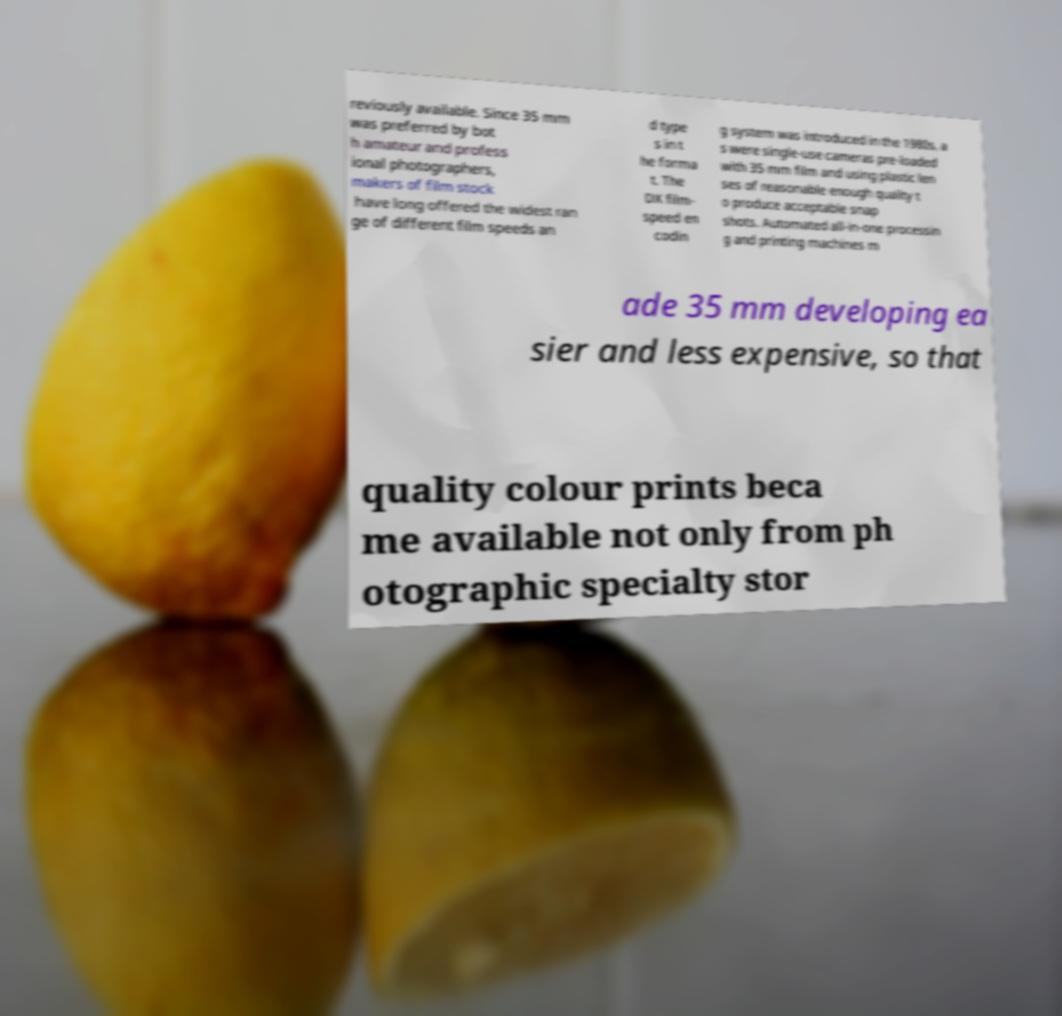Can you read and provide the text displayed in the image?This photo seems to have some interesting text. Can you extract and type it out for me? reviously available. Since 35 mm was preferred by bot h amateur and profess ional photographers, makers of film stock have long offered the widest ran ge of different film speeds an d type s in t he forma t. The DX film- speed en codin g system was introduced in the 1980s, a s were single-use cameras pre-loaded with 35 mm film and using plastic len ses of reasonable enough quality t o produce acceptable snap shots. Automated all-in-one processin g and printing machines m ade 35 mm developing ea sier and less expensive, so that quality colour prints beca me available not only from ph otographic specialty stor 